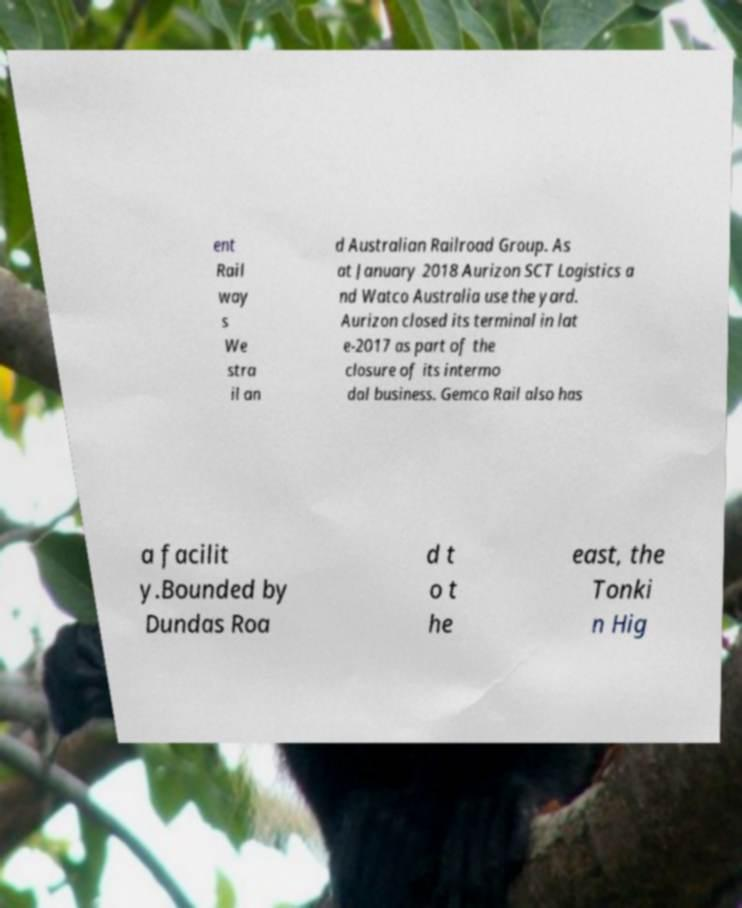What messages or text are displayed in this image? I need them in a readable, typed format. ent Rail way s We stra il an d Australian Railroad Group. As at January 2018 Aurizon SCT Logistics a nd Watco Australia use the yard. Aurizon closed its terminal in lat e-2017 as part of the closure of its intermo dal business. Gemco Rail also has a facilit y.Bounded by Dundas Roa d t o t he east, the Tonki n Hig 